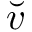<formula> <loc_0><loc_0><loc_500><loc_500>\breve { v }</formula> 